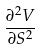<formula> <loc_0><loc_0><loc_500><loc_500>\frac { \partial ^ { 2 } V } { \partial S ^ { 2 } }</formula> 